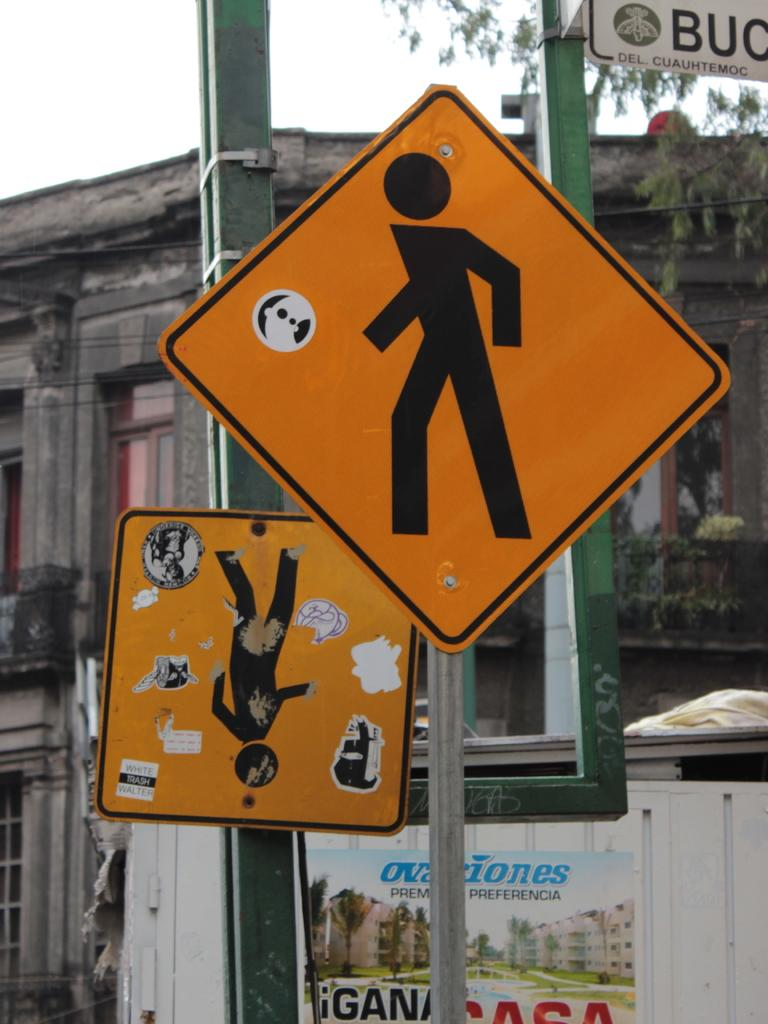<image>
Describe the image concisely. A sign on the lower part of the white building has preferencia on it. 